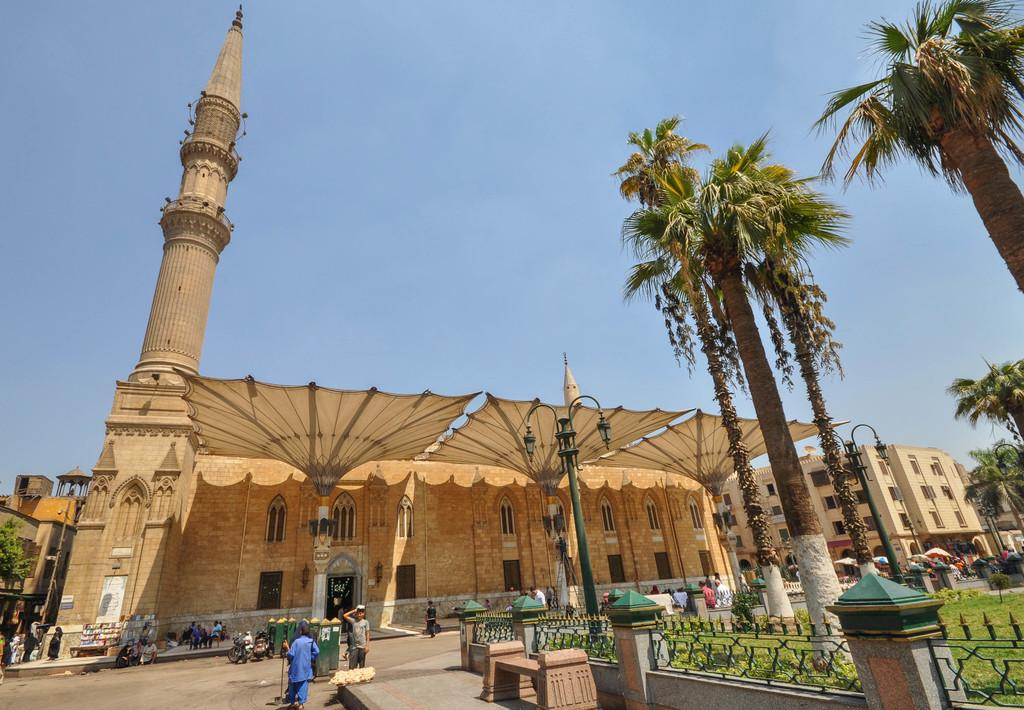What are the people in the image doing? The people in the image are walking on the road. What can be seen along the road in the image? There is a fence in the image. What type of vegetation is present in the image? There are trees in the image. What type of temporary shelter is visible in the image? There are tents in the image. What structures are present to provide light at night? There are light poles in the image. What type of permanent structures can be seen in the image? There are buildings in the image. What is visible in the background of the image? The sky is visible in the background of the image. Can you tell me how many owls are sitting on the light poles in the image? There are no owls present in the image; only people, a fence, trees, tents, light poles, buildings, and the sky are visible. What type of books can be seen on the tents in the image? There are no books present in the image; only people, a fence, trees, tents, light poles, buildings, and the sky are visible. 